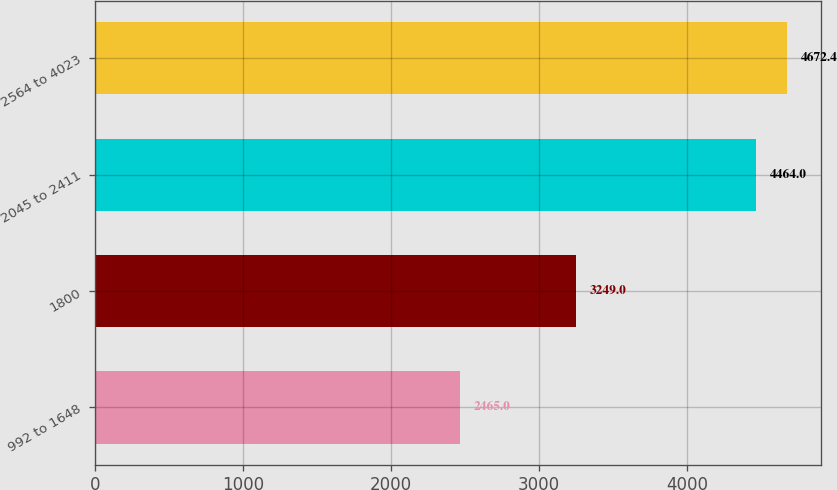Convert chart. <chart><loc_0><loc_0><loc_500><loc_500><bar_chart><fcel>992 to 1648<fcel>1800<fcel>2045 to 2411<fcel>2564 to 4023<nl><fcel>2465<fcel>3249<fcel>4464<fcel>4672.4<nl></chart> 